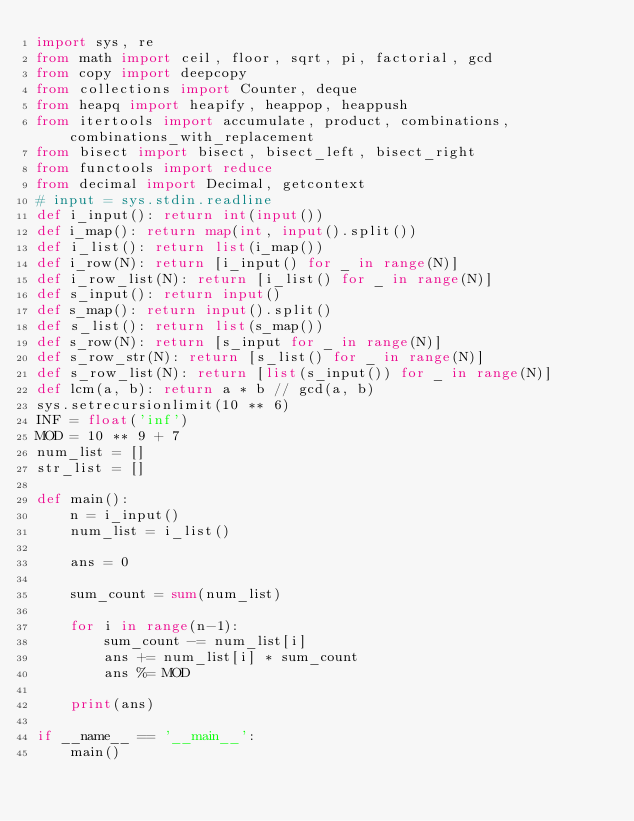Convert code to text. <code><loc_0><loc_0><loc_500><loc_500><_Python_>import sys, re
from math import ceil, floor, sqrt, pi, factorial, gcd
from copy import deepcopy
from collections import Counter, deque
from heapq import heapify, heappop, heappush
from itertools import accumulate, product, combinations, combinations_with_replacement
from bisect import bisect, bisect_left, bisect_right
from functools import reduce
from decimal import Decimal, getcontext
# input = sys.stdin.readline 
def i_input(): return int(input())
def i_map(): return map(int, input().split())
def i_list(): return list(i_map())
def i_row(N): return [i_input() for _ in range(N)]
def i_row_list(N): return [i_list() for _ in range(N)]
def s_input(): return input()
def s_map(): return input().split()
def s_list(): return list(s_map())
def s_row(N): return [s_input for _ in range(N)]
def s_row_str(N): return [s_list() for _ in range(N)]
def s_row_list(N): return [list(s_input()) for _ in range(N)]
def lcm(a, b): return a * b // gcd(a, b)
sys.setrecursionlimit(10 ** 6)
INF = float('inf')
MOD = 10 ** 9 + 7
num_list = []
str_list = []

def main():
    n = i_input()
    num_list = i_list()

    ans = 0

    sum_count = sum(num_list)

    for i in range(n-1):
        sum_count -= num_list[i]
        ans += num_list[i] * sum_count
        ans %= MOD

    print(ans)

if __name__ == '__main__':
    main()
</code> 